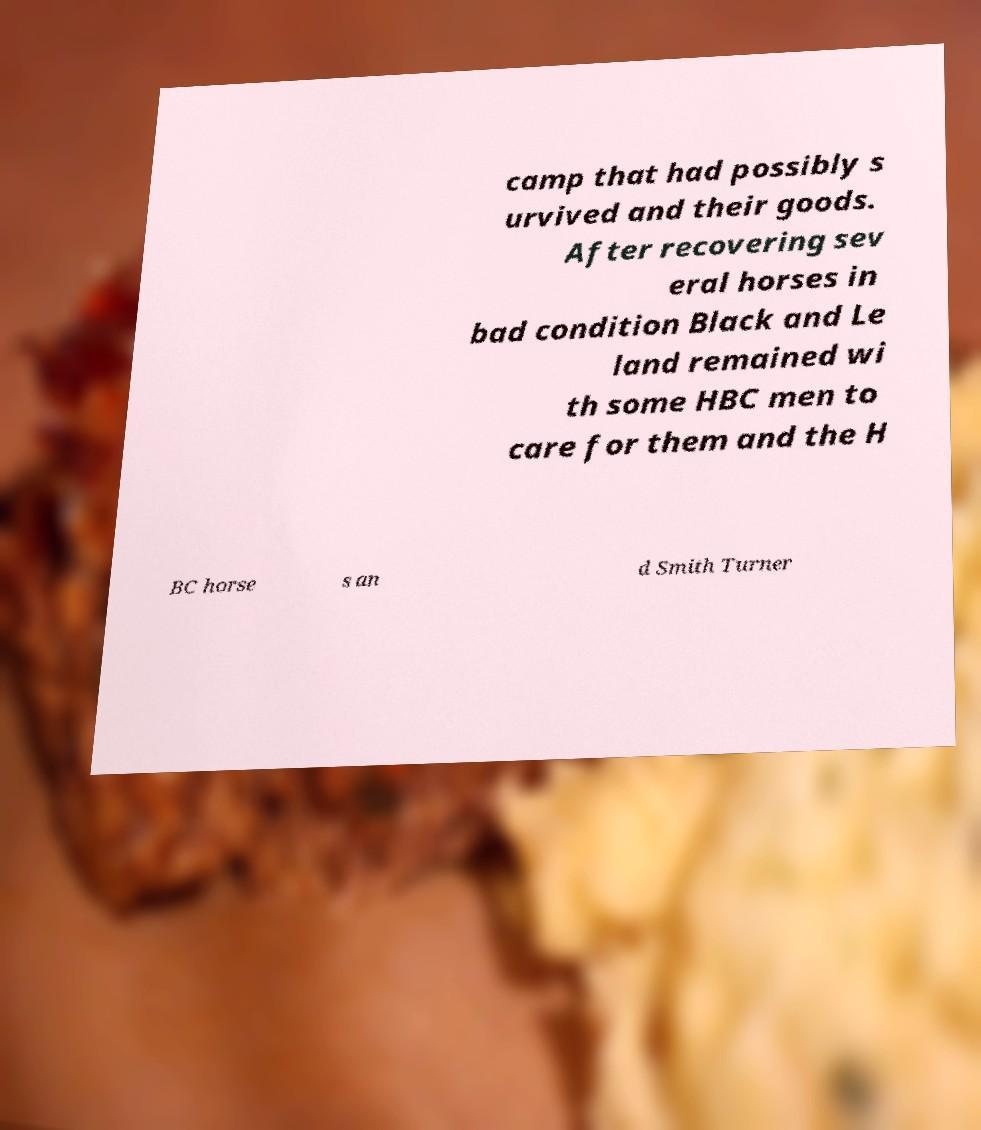Can you read and provide the text displayed in the image?This photo seems to have some interesting text. Can you extract and type it out for me? camp that had possibly s urvived and their goods. After recovering sev eral horses in bad condition Black and Le land remained wi th some HBC men to care for them and the H BC horse s an d Smith Turner 